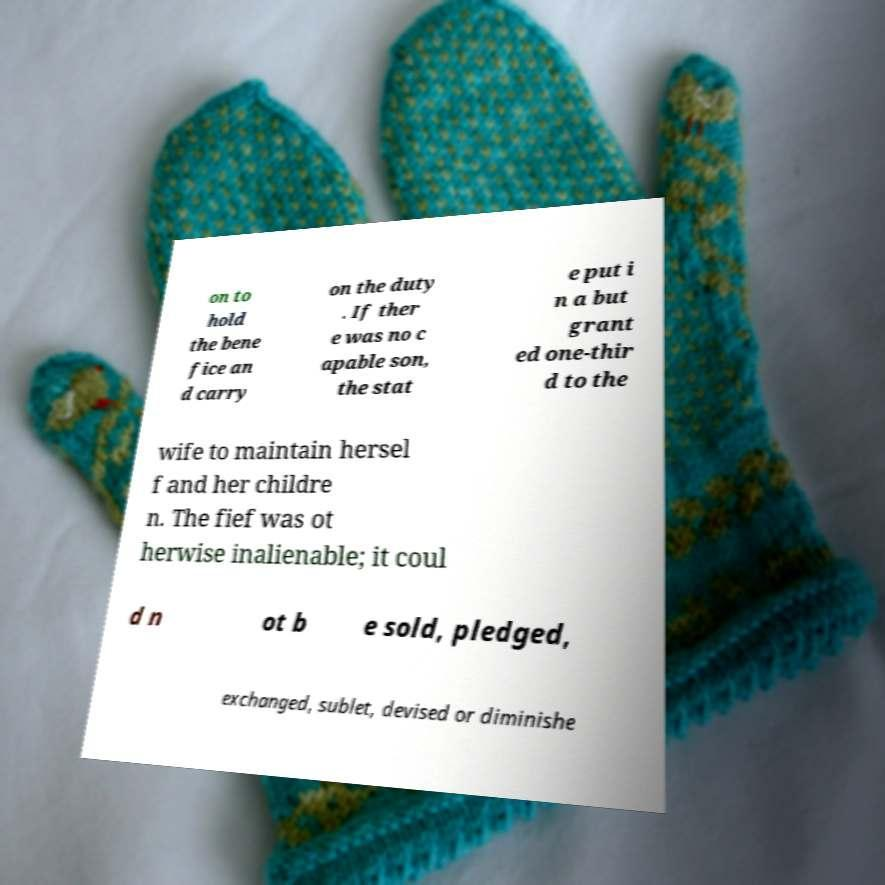For documentation purposes, I need the text within this image transcribed. Could you provide that? on to hold the bene fice an d carry on the duty . If ther e was no c apable son, the stat e put i n a but grant ed one-thir d to the wife to maintain hersel f and her childre n. The fief was ot herwise inalienable; it coul d n ot b e sold, pledged, exchanged, sublet, devised or diminishe 